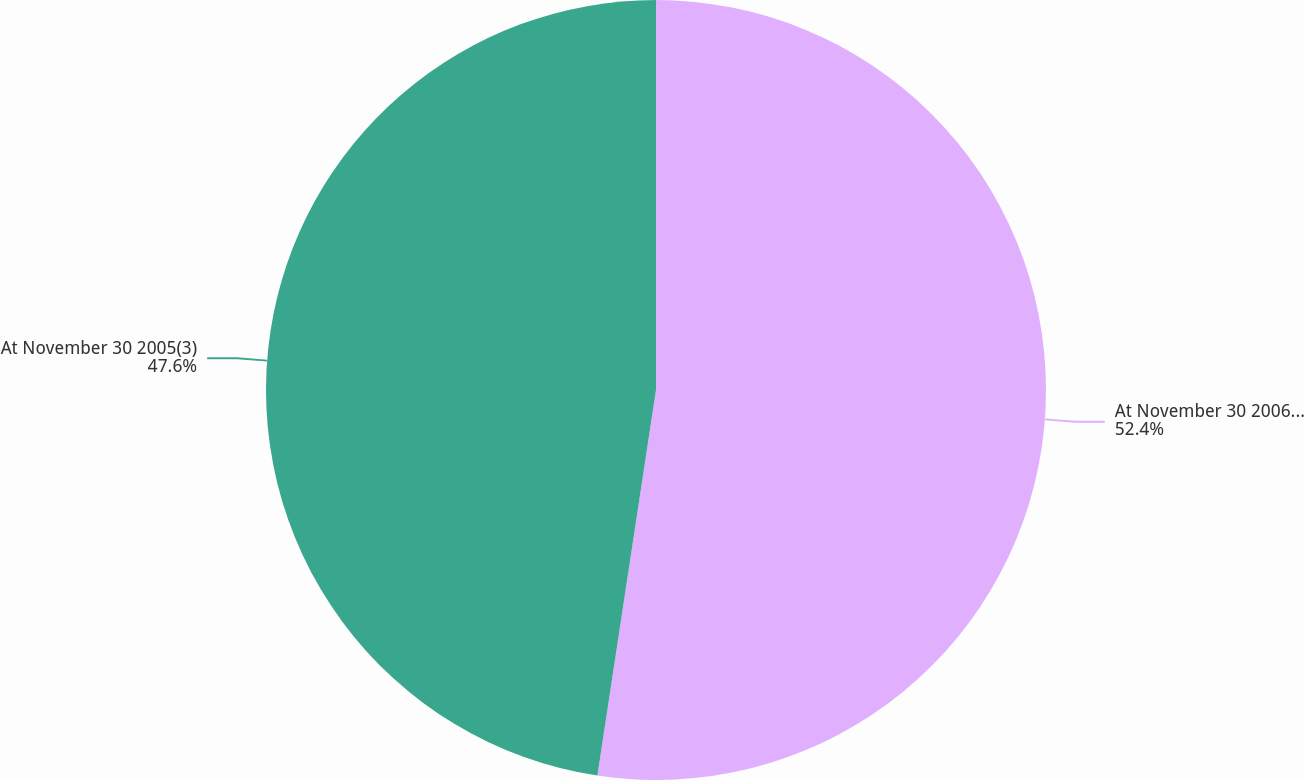Convert chart to OTSL. <chart><loc_0><loc_0><loc_500><loc_500><pie_chart><fcel>At November 30 2006(3)<fcel>At November 30 2005(3)<nl><fcel>52.4%<fcel>47.6%<nl></chart> 